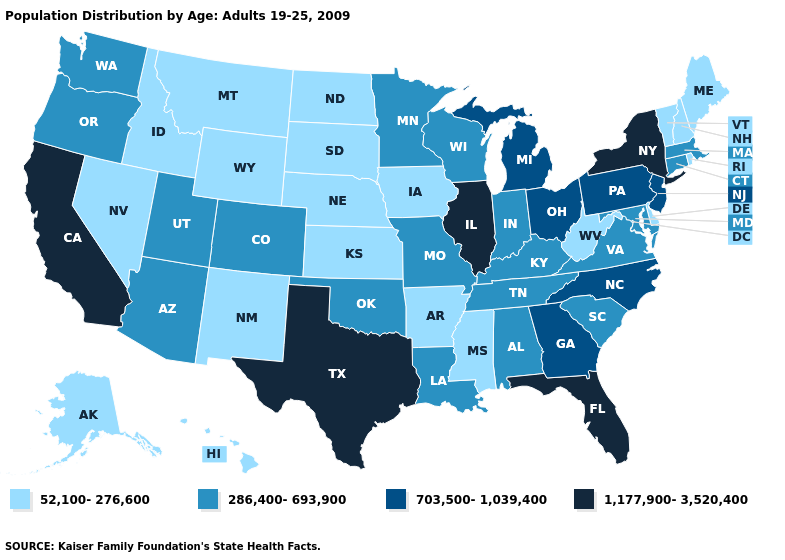Does the map have missing data?
Quick response, please. No. Does South Carolina have a higher value than Minnesota?
Concise answer only. No. Name the states that have a value in the range 703,500-1,039,400?
Quick response, please. Georgia, Michigan, New Jersey, North Carolina, Ohio, Pennsylvania. Name the states that have a value in the range 286,400-693,900?
Short answer required. Alabama, Arizona, Colorado, Connecticut, Indiana, Kentucky, Louisiana, Maryland, Massachusetts, Minnesota, Missouri, Oklahoma, Oregon, South Carolina, Tennessee, Utah, Virginia, Washington, Wisconsin. Among the states that border Tennessee , does Virginia have the highest value?
Be succinct. No. Is the legend a continuous bar?
Answer briefly. No. Which states have the lowest value in the West?
Answer briefly. Alaska, Hawaii, Idaho, Montana, Nevada, New Mexico, Wyoming. Does Mississippi have a higher value than Maryland?
Give a very brief answer. No. Does Nevada have the highest value in the West?
Quick response, please. No. Name the states that have a value in the range 286,400-693,900?
Write a very short answer. Alabama, Arizona, Colorado, Connecticut, Indiana, Kentucky, Louisiana, Maryland, Massachusetts, Minnesota, Missouri, Oklahoma, Oregon, South Carolina, Tennessee, Utah, Virginia, Washington, Wisconsin. What is the lowest value in the Northeast?
Write a very short answer. 52,100-276,600. Does the map have missing data?
Write a very short answer. No. What is the value of Mississippi?
Be succinct. 52,100-276,600. Name the states that have a value in the range 703,500-1,039,400?
Answer briefly. Georgia, Michigan, New Jersey, North Carolina, Ohio, Pennsylvania. Which states have the highest value in the USA?
Short answer required. California, Florida, Illinois, New York, Texas. 